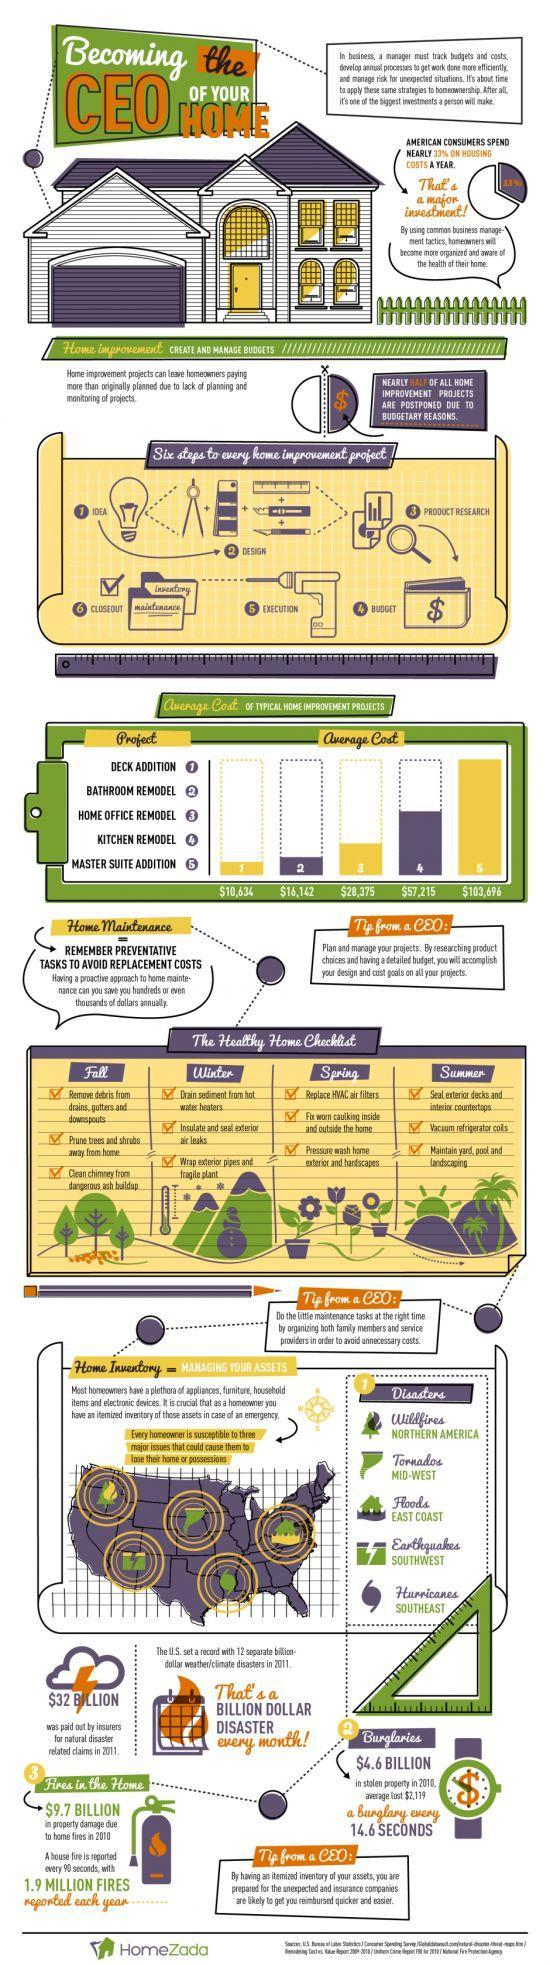What is the amount paid by insurers for natural disaster related claims in 2011?
Answer the question with a short phrase. $32 BILLION Which natural disaster can cause people to lose their home or possessions in Northern America? Wildfires Which home improvement project has the least average cost? DECK ADDITION What is the average cost estimate for deck addition project? $10,634 Which natural disaster can cause people to lose their home or possessions in SouthWest America? Earthquakes What is the average cost estimate for kitchen remodelling project? $57,215 What is the average cost estimate for bathroom remodelling project? $16,142 What percentage is spend on housing cost by American consumers per year? 33% Which home improvement project has the highest average cost? MASTER SUITE ADDITION 